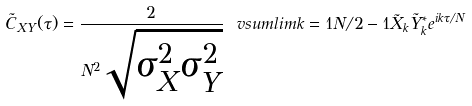Convert formula to latex. <formula><loc_0><loc_0><loc_500><loc_500>\tilde { C } _ { X Y } ( \tau ) = \frac { 2 } { N ^ { 2 } \sqrt { \sigma ^ { 2 } _ { X } \sigma ^ { 2 } _ { Y } } } \ v s u m l i m { k = 1 } { N / 2 - 1 } { \tilde { X } } _ { k } { \tilde { Y } } _ { k } ^ { * } e ^ { { i k \tau } / { N } }</formula> 